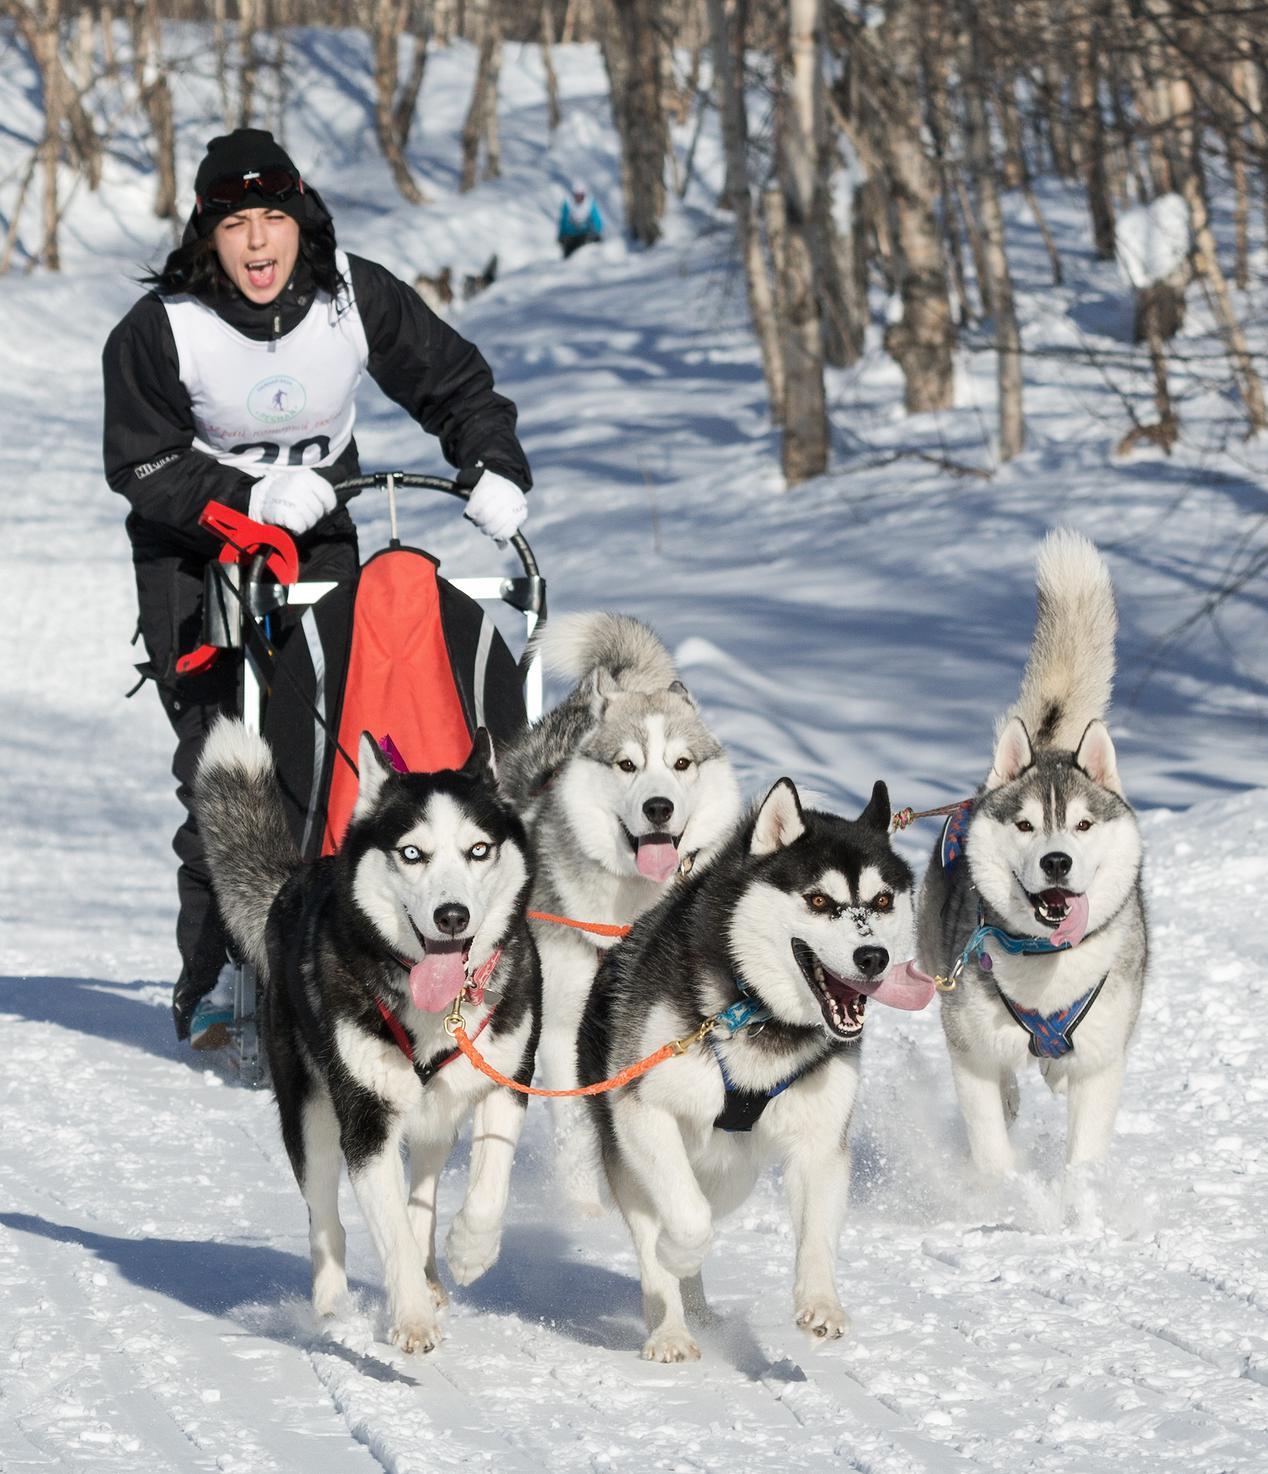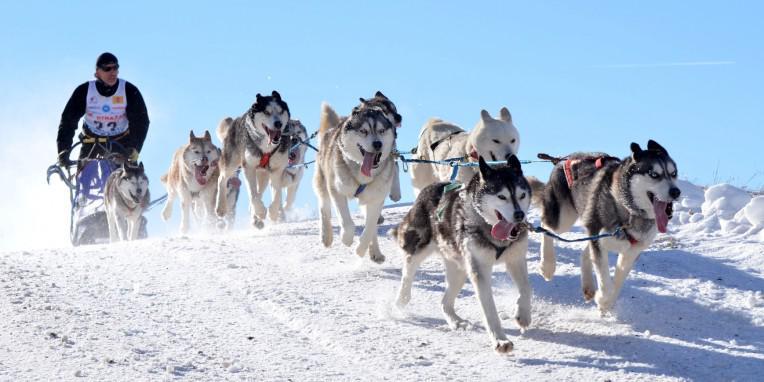The first image is the image on the left, the second image is the image on the right. Examine the images to the left and right. Is the description "One of the pictures shows more than one human being pulled by the dogs." accurate? Answer yes or no. No. The first image is the image on the left, the second image is the image on the right. For the images shown, is this caption "A person wearing a blue jacket is driving the sled in the photo on the right.." true? Answer yes or no. No. 